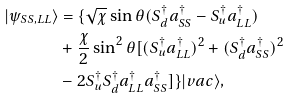Convert formula to latex. <formula><loc_0><loc_0><loc_500><loc_500>| \psi _ { S S , L L } \rangle & = \{ \sqrt { \chi } \sin { \theta } ( S _ { d } ^ { \dag } a _ { S S } ^ { \dag } - S _ { u } ^ { \dag } a _ { L L } ^ { \dag } ) \\ & + \frac { \chi } { 2 } \sin ^ { 2 } { \theta } [ ( S _ { u } ^ { \dag } a _ { L L } ^ { \dag } ) ^ { 2 } + ( S _ { d } ^ { \dag } a _ { S S } ^ { \dag } ) ^ { 2 } \\ & - 2 S _ { u } ^ { \dag } S _ { d } ^ { \dag } a _ { L L } ^ { \dag } a _ { S S } ^ { \dag } ] \} | v a c \rangle ,</formula> 